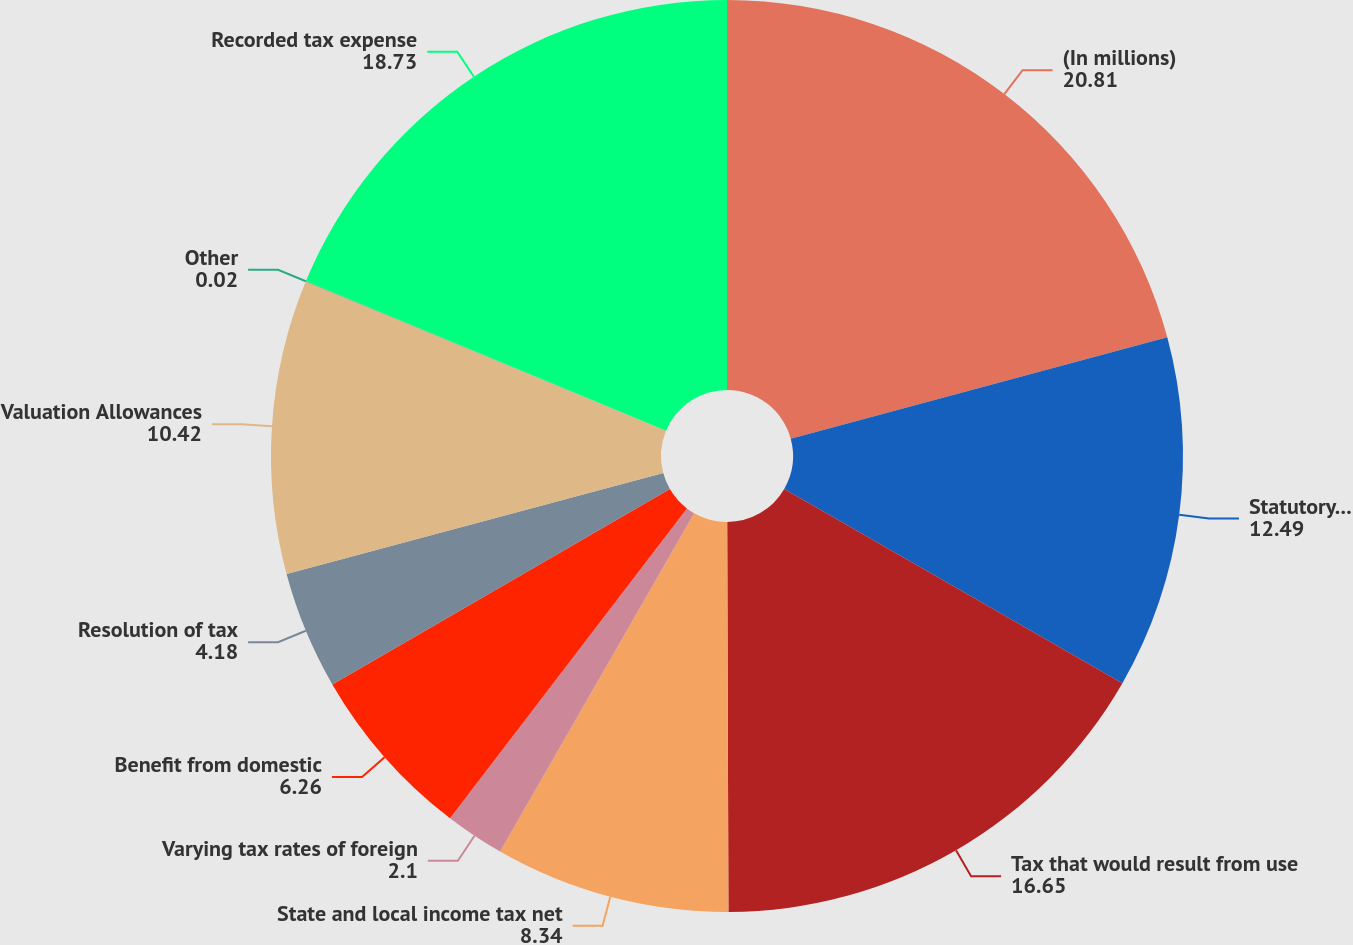Convert chart to OTSL. <chart><loc_0><loc_0><loc_500><loc_500><pie_chart><fcel>(In millions)<fcel>Statutory rate<fcel>Tax that would result from use<fcel>State and local income tax net<fcel>Varying tax rates of foreign<fcel>Benefit from domestic<fcel>Resolution of tax<fcel>Valuation Allowances<fcel>Other<fcel>Recorded tax expense<nl><fcel>20.81%<fcel>12.49%<fcel>16.65%<fcel>8.34%<fcel>2.1%<fcel>6.26%<fcel>4.18%<fcel>10.42%<fcel>0.02%<fcel>18.73%<nl></chart> 